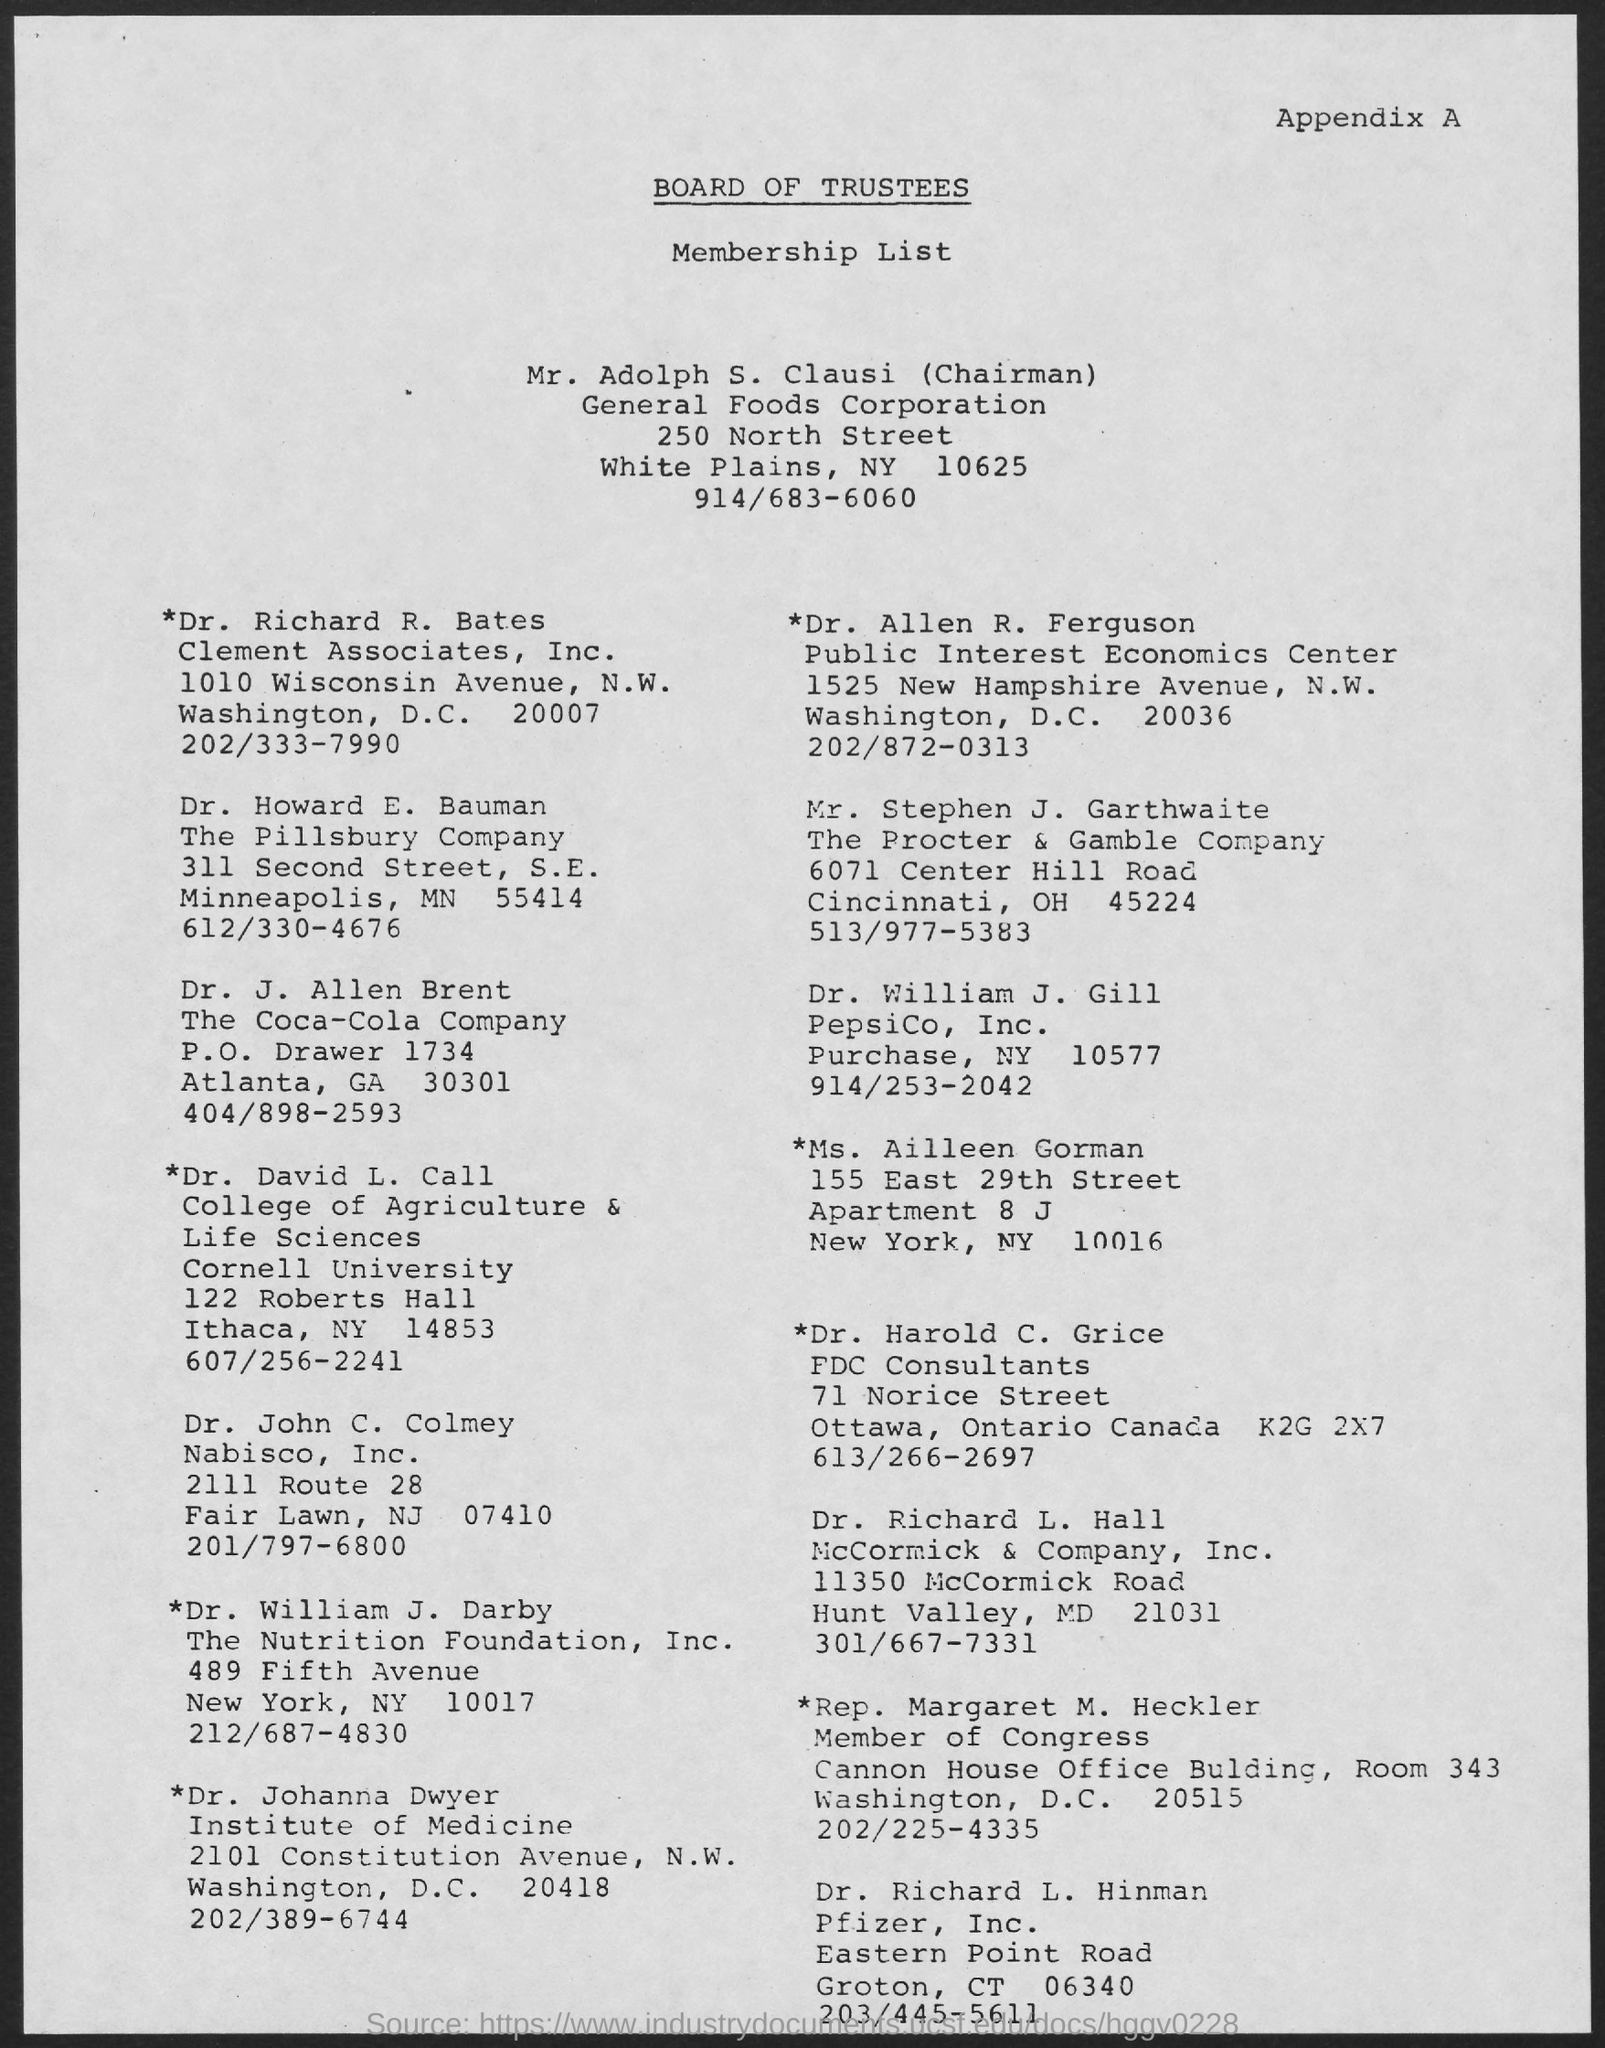What is the Title of the document?
Your answer should be compact. Board of Trustees. Who is the Chairman?
Keep it short and to the point. Mr. Adolph S. Clausi. 